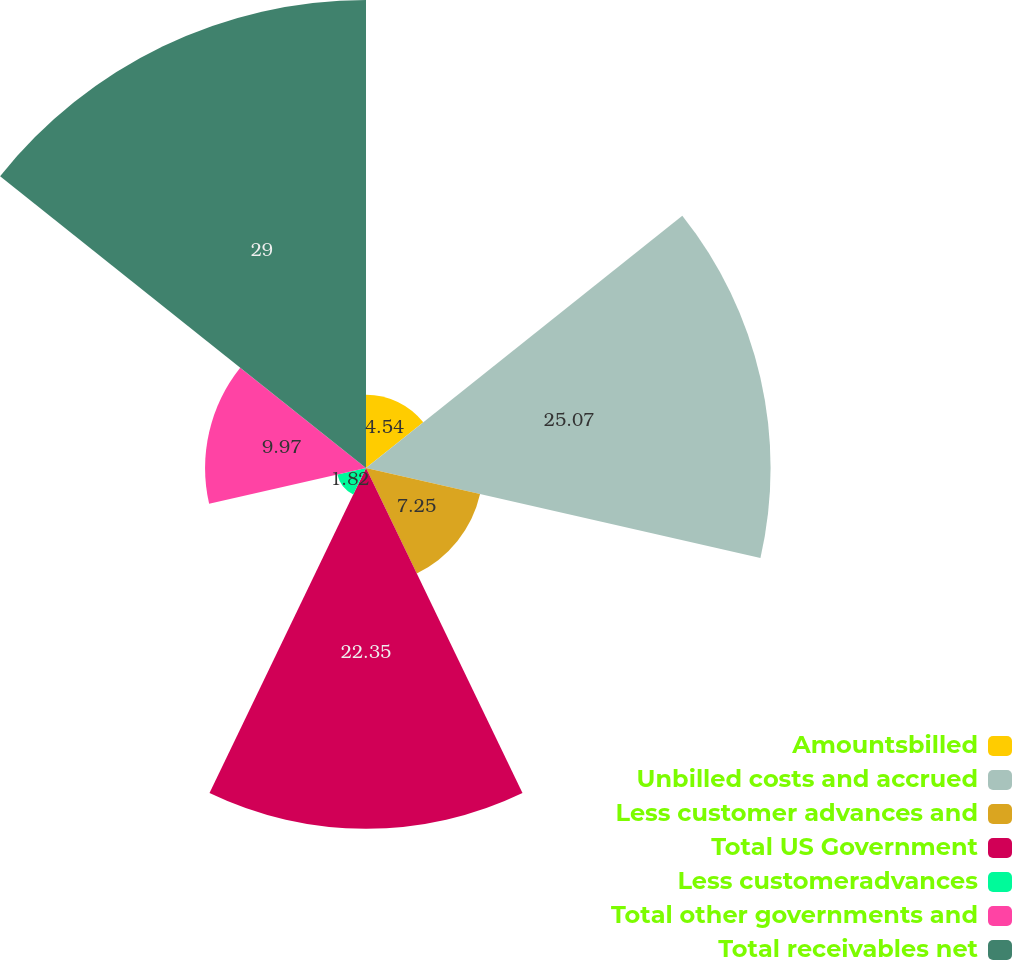Convert chart to OTSL. <chart><loc_0><loc_0><loc_500><loc_500><pie_chart><fcel>Amountsbilled<fcel>Unbilled costs and accrued<fcel>Less customer advances and<fcel>Total US Government<fcel>Less customeradvances<fcel>Total other governments and<fcel>Total receivables net<nl><fcel>4.54%<fcel>25.07%<fcel>7.25%<fcel>22.35%<fcel>1.82%<fcel>9.97%<fcel>29.0%<nl></chart> 